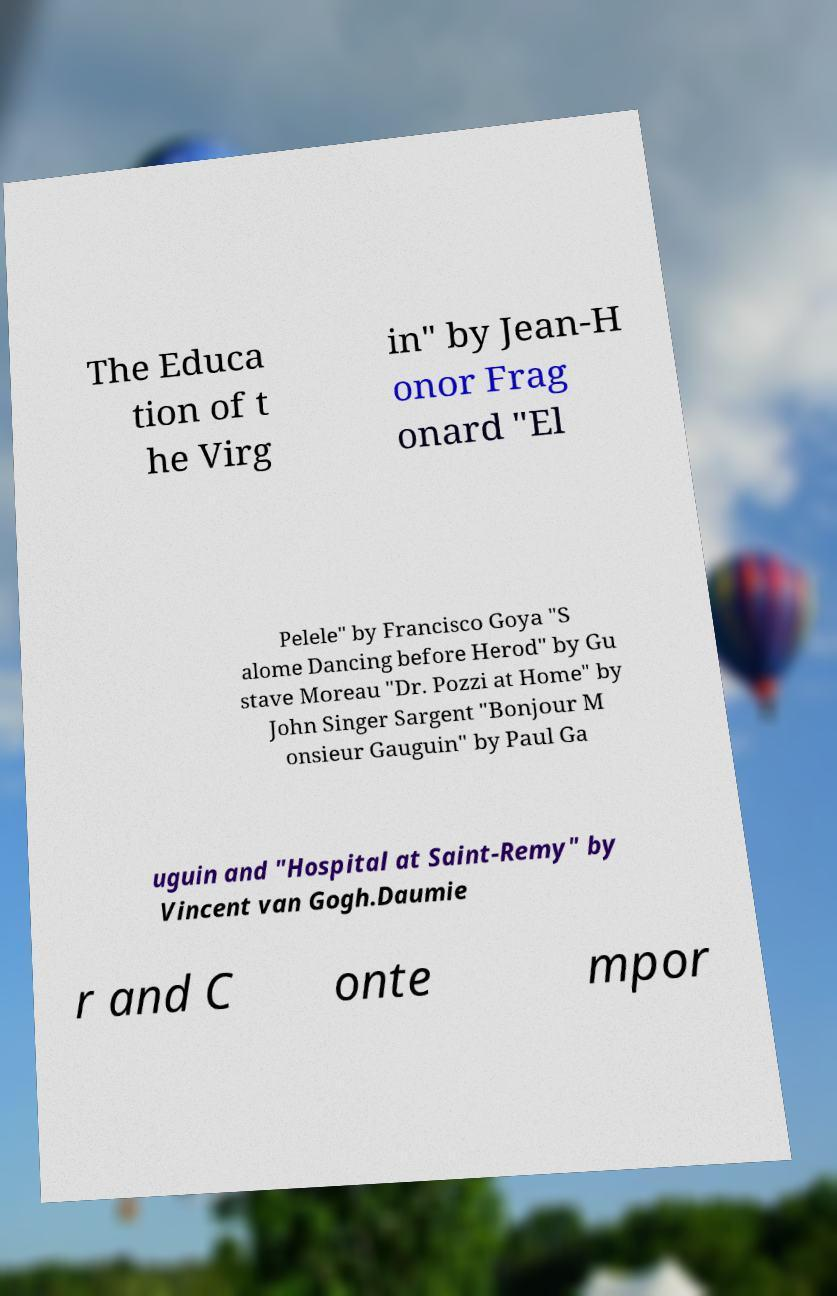What messages or text are displayed in this image? I need them in a readable, typed format. The Educa tion of t he Virg in" by Jean-H onor Frag onard "El Pelele" by Francisco Goya "S alome Dancing before Herod" by Gu stave Moreau "Dr. Pozzi at Home" by John Singer Sargent "Bonjour M onsieur Gauguin" by Paul Ga uguin and "Hospital at Saint-Remy" by Vincent van Gogh.Daumie r and C onte mpor 